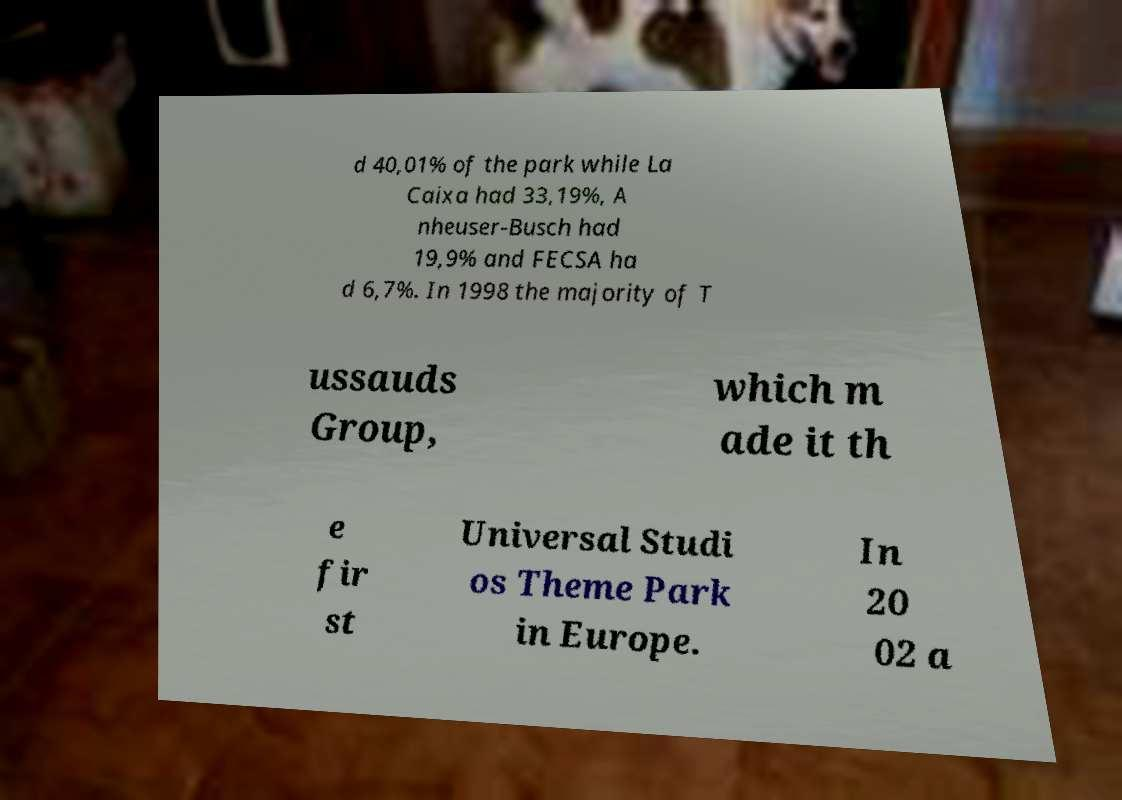Can you read and provide the text displayed in the image?This photo seems to have some interesting text. Can you extract and type it out for me? d 40,01% of the park while La Caixa had 33,19%, A nheuser-Busch had 19,9% and FECSA ha d 6,7%. In 1998 the majority of T ussauds Group, which m ade it th e fir st Universal Studi os Theme Park in Europe. In 20 02 a 